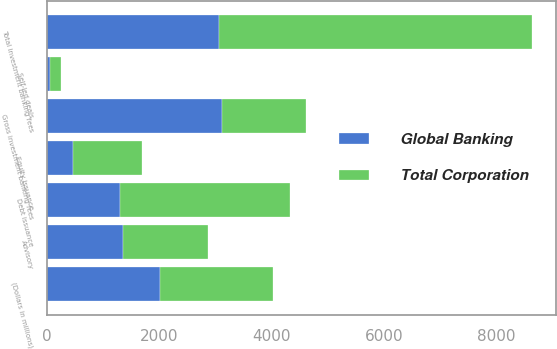<chart> <loc_0><loc_0><loc_500><loc_500><stacked_bar_chart><ecel><fcel>(Dollars in millions)<fcel>Advisory<fcel>Debt issuance<fcel>Equity issuance<fcel>Gross investment banking fees<fcel>Self-led deals<fcel>Total investment banking fees<nl><fcel>Global Banking<fcel>2015<fcel>1354<fcel>1296<fcel>460<fcel>3110<fcel>57<fcel>3053<nl><fcel>Total Corporation<fcel>2015<fcel>1503<fcel>3033<fcel>1236<fcel>1503<fcel>200<fcel>5572<nl></chart> 